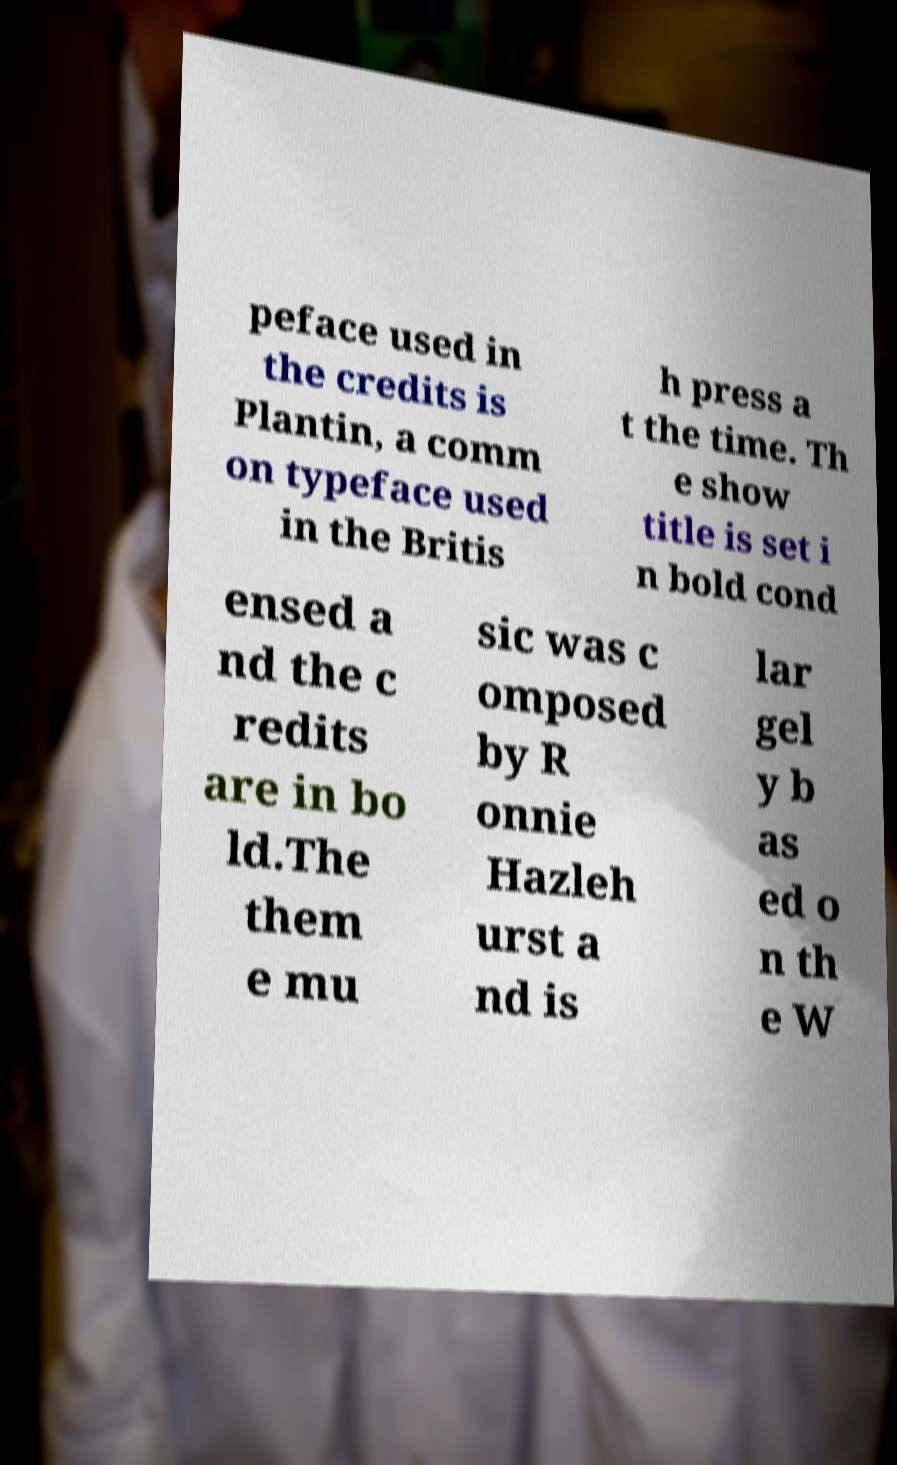Could you assist in decoding the text presented in this image and type it out clearly? peface used in the credits is Plantin, a comm on typeface used in the Britis h press a t the time. Th e show title is set i n bold cond ensed a nd the c redits are in bo ld.The them e mu sic was c omposed by R onnie Hazleh urst a nd is lar gel y b as ed o n th e W 